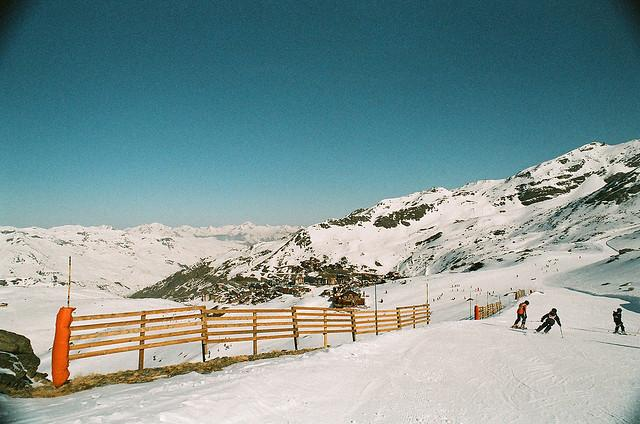What use is the fencing shown here? separation 